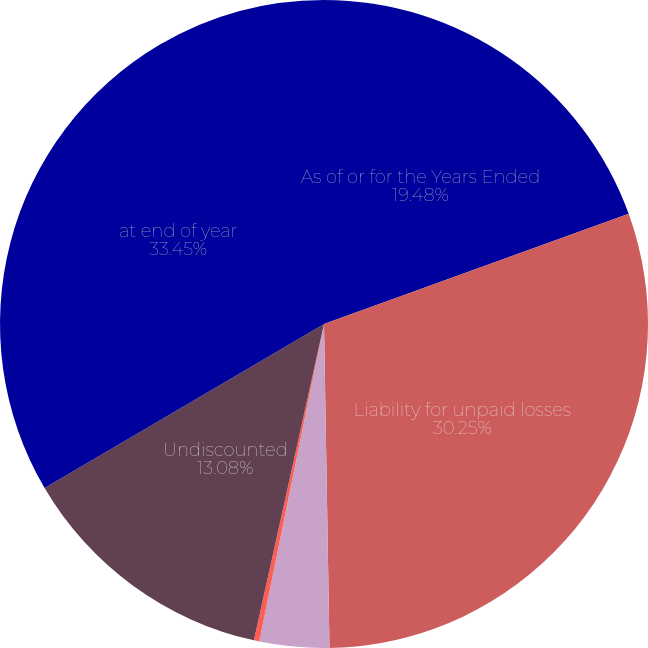Convert chart to OTSL. <chart><loc_0><loc_0><loc_500><loc_500><pie_chart><fcel>As of or for the Years Ended<fcel>Liability for unpaid losses<fcel>Change in discount<fcel>Losses and loss adjustment<fcel>Undiscounted<fcel>at end of year<nl><fcel>19.48%<fcel>30.25%<fcel>3.47%<fcel>0.27%<fcel>13.08%<fcel>33.45%<nl></chart> 